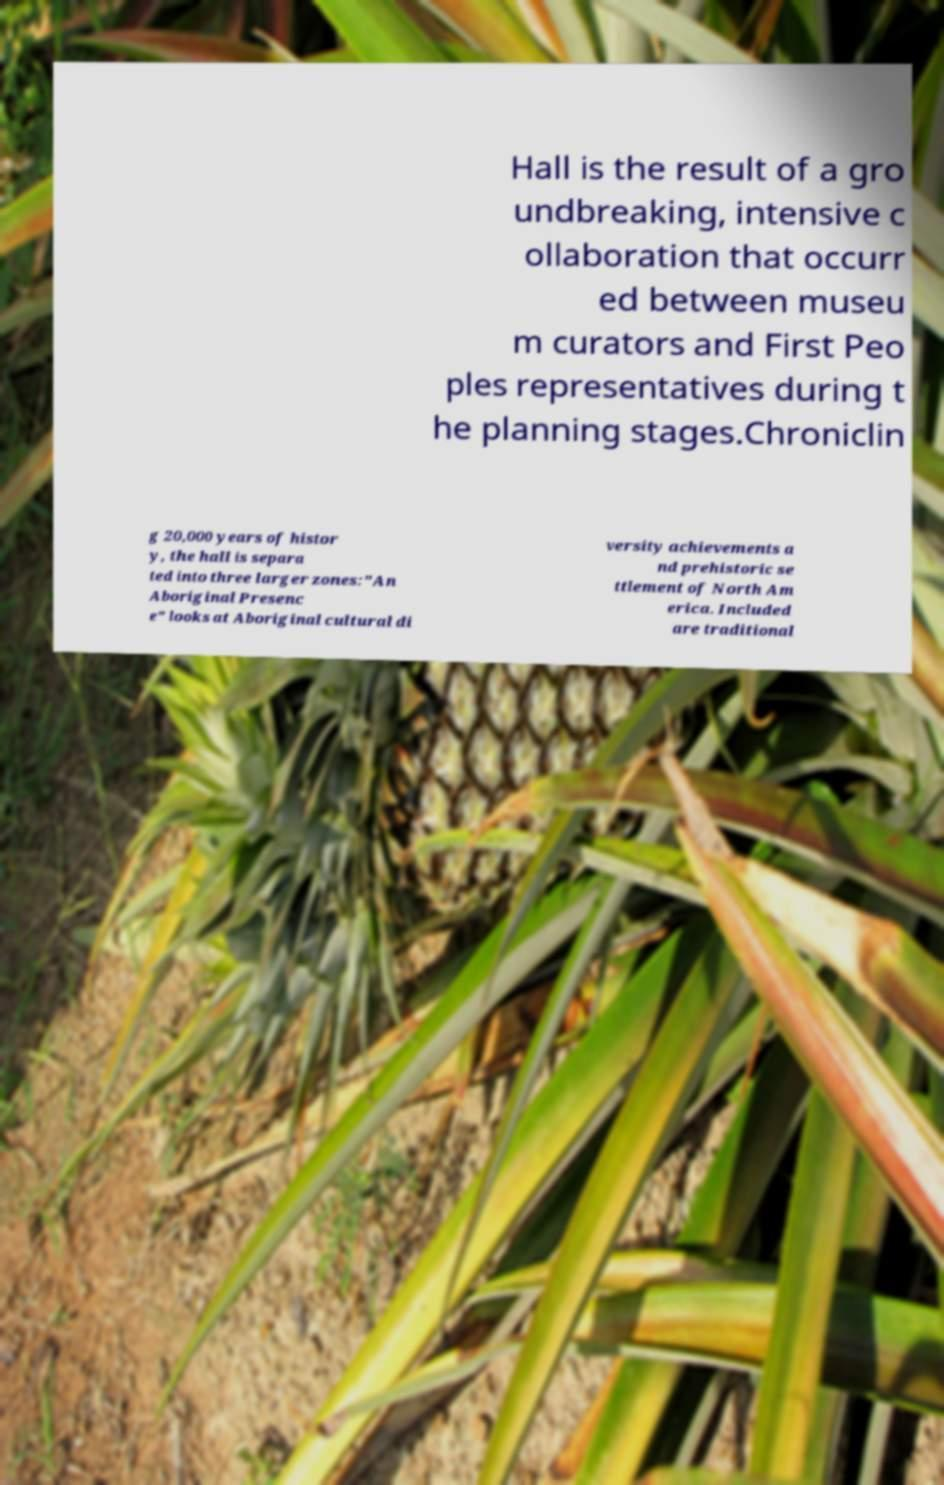Can you read and provide the text displayed in the image?This photo seems to have some interesting text. Can you extract and type it out for me? Hall is the result of a gro undbreaking, intensive c ollaboration that occurr ed between museu m curators and First Peo ples representatives during t he planning stages.Chroniclin g 20,000 years of histor y, the hall is separa ted into three larger zones:"An Aboriginal Presenc e" looks at Aboriginal cultural di versity achievements a nd prehistoric se ttlement of North Am erica. Included are traditional 